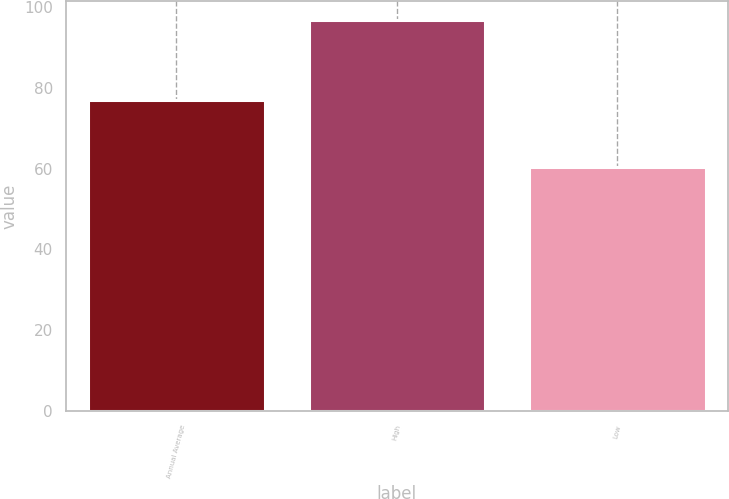Convert chart to OTSL. <chart><loc_0><loc_0><loc_500><loc_500><bar_chart><fcel>Annual Average<fcel>High<fcel>Low<nl><fcel>76.9<fcel>96.7<fcel>60.3<nl></chart> 